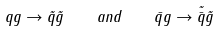<formula> <loc_0><loc_0><loc_500><loc_500>q g \to \tilde { q } \tilde { g } \quad a n d \quad \bar { q } g \to \tilde { \bar { q } } \tilde { g }</formula> 